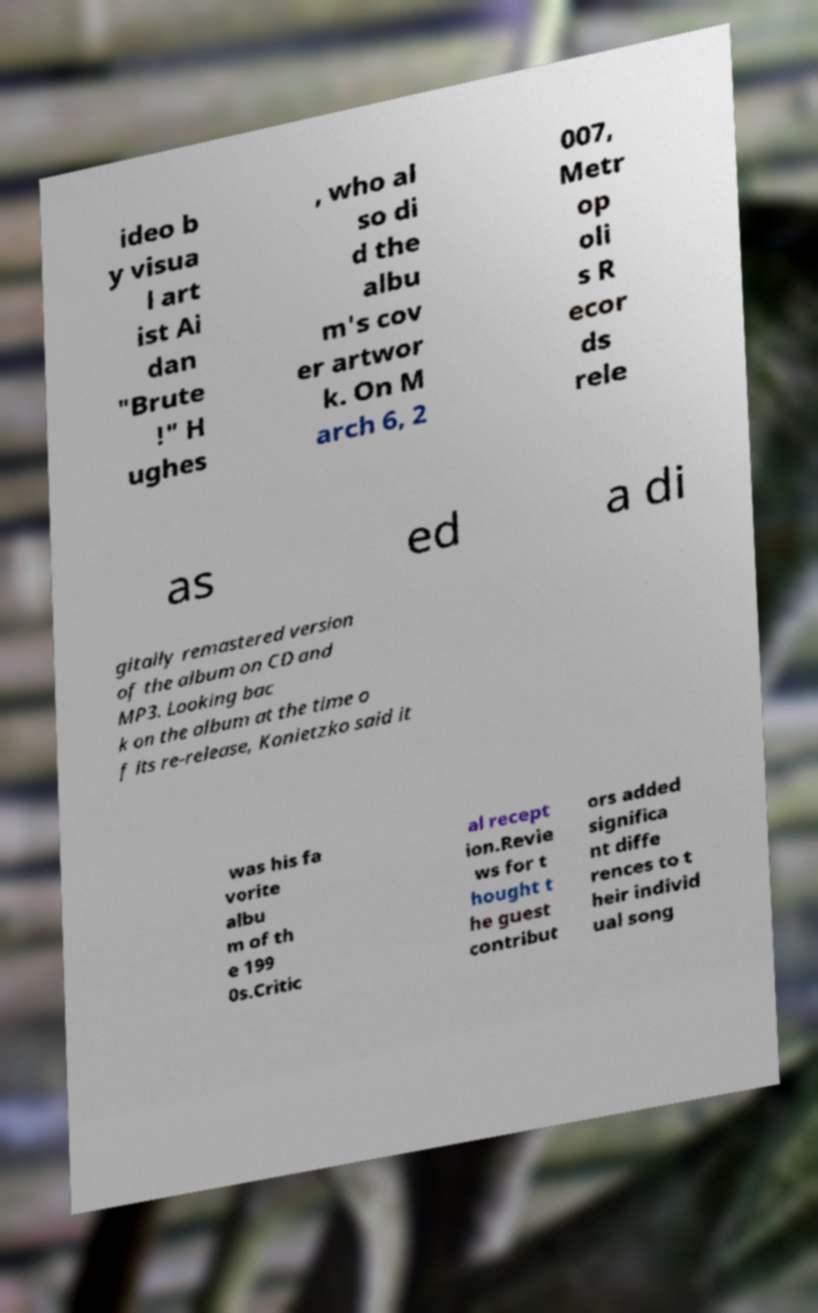Could you assist in decoding the text presented in this image and type it out clearly? ideo b y visua l art ist Ai dan "Brute !" H ughes , who al so di d the albu m's cov er artwor k. On M arch 6, 2 007, Metr op oli s R ecor ds rele as ed a di gitally remastered version of the album on CD and MP3. Looking bac k on the album at the time o f its re-release, Konietzko said it was his fa vorite albu m of th e 199 0s.Critic al recept ion.Revie ws for t hought t he guest contribut ors added significa nt diffe rences to t heir individ ual song 